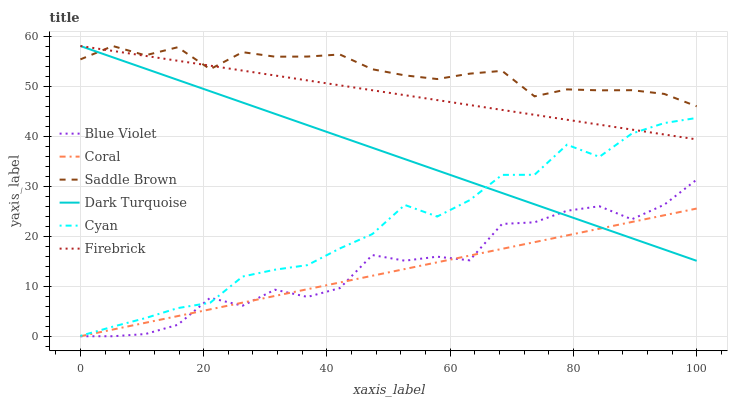Does Coral have the minimum area under the curve?
Answer yes or no. Yes. Does Saddle Brown have the maximum area under the curve?
Answer yes or no. Yes. Does Saddle Brown have the minimum area under the curve?
Answer yes or no. No. Does Coral have the maximum area under the curve?
Answer yes or no. No. Is Coral the smoothest?
Answer yes or no. Yes. Is Blue Violet the roughest?
Answer yes or no. Yes. Is Saddle Brown the smoothest?
Answer yes or no. No. Is Saddle Brown the roughest?
Answer yes or no. No. Does Coral have the lowest value?
Answer yes or no. Yes. Does Saddle Brown have the lowest value?
Answer yes or no. No. Does Firebrick have the highest value?
Answer yes or no. Yes. Does Coral have the highest value?
Answer yes or no. No. Is Coral less than Cyan?
Answer yes or no. Yes. Is Firebrick greater than Coral?
Answer yes or no. Yes. Does Firebrick intersect Saddle Brown?
Answer yes or no. Yes. Is Firebrick less than Saddle Brown?
Answer yes or no. No. Is Firebrick greater than Saddle Brown?
Answer yes or no. No. Does Coral intersect Cyan?
Answer yes or no. No. 